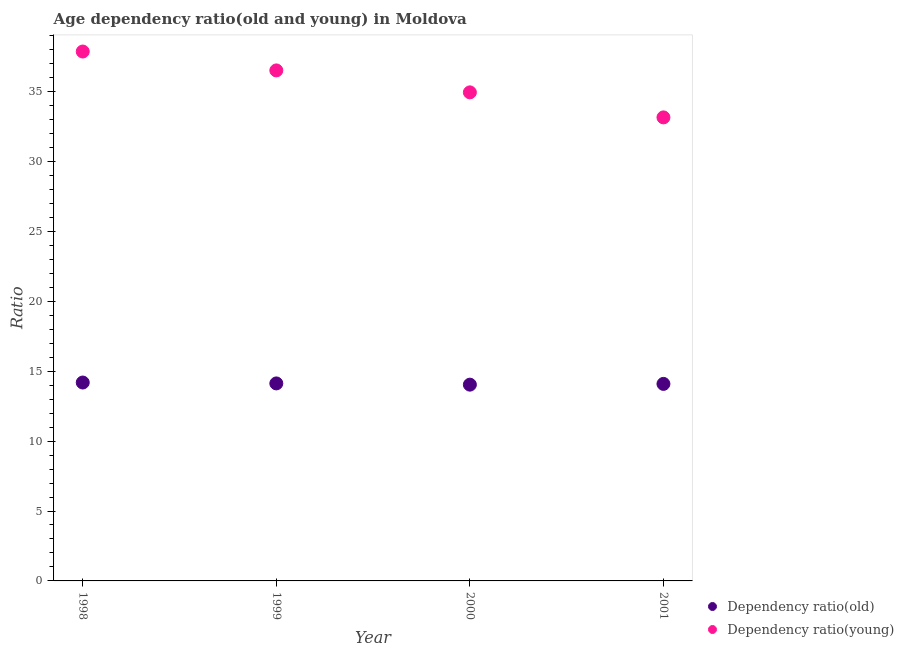Is the number of dotlines equal to the number of legend labels?
Offer a terse response. Yes. What is the age dependency ratio(young) in 1999?
Give a very brief answer. 36.51. Across all years, what is the maximum age dependency ratio(old)?
Keep it short and to the point. 14.19. Across all years, what is the minimum age dependency ratio(young)?
Provide a short and direct response. 33.15. What is the total age dependency ratio(young) in the graph?
Your answer should be compact. 142.48. What is the difference between the age dependency ratio(old) in 1999 and that in 2001?
Keep it short and to the point. 0.03. What is the difference between the age dependency ratio(old) in 2000 and the age dependency ratio(young) in 1998?
Offer a very short reply. -23.83. What is the average age dependency ratio(old) per year?
Ensure brevity in your answer.  14.11. In the year 2000, what is the difference between the age dependency ratio(young) and age dependency ratio(old)?
Provide a succinct answer. 20.91. In how many years, is the age dependency ratio(old) greater than 25?
Give a very brief answer. 0. What is the ratio of the age dependency ratio(young) in 1998 to that in 2001?
Your answer should be compact. 1.14. What is the difference between the highest and the second highest age dependency ratio(young)?
Offer a very short reply. 1.35. What is the difference between the highest and the lowest age dependency ratio(old)?
Give a very brief answer. 0.15. Does the age dependency ratio(old) monotonically increase over the years?
Ensure brevity in your answer.  No. Is the age dependency ratio(young) strictly greater than the age dependency ratio(old) over the years?
Give a very brief answer. Yes. How many dotlines are there?
Give a very brief answer. 2. How many years are there in the graph?
Your answer should be very brief. 4. Are the values on the major ticks of Y-axis written in scientific E-notation?
Provide a short and direct response. No. Where does the legend appear in the graph?
Offer a very short reply. Bottom right. How many legend labels are there?
Offer a terse response. 2. How are the legend labels stacked?
Your answer should be compact. Vertical. What is the title of the graph?
Your answer should be very brief. Age dependency ratio(old and young) in Moldova. What is the label or title of the Y-axis?
Keep it short and to the point. Ratio. What is the Ratio of Dependency ratio(old) in 1998?
Provide a short and direct response. 14.19. What is the Ratio in Dependency ratio(young) in 1998?
Give a very brief answer. 37.86. What is the Ratio in Dependency ratio(old) in 1999?
Give a very brief answer. 14.13. What is the Ratio in Dependency ratio(young) in 1999?
Provide a short and direct response. 36.51. What is the Ratio in Dependency ratio(old) in 2000?
Make the answer very short. 14.04. What is the Ratio in Dependency ratio(young) in 2000?
Your response must be concise. 34.94. What is the Ratio in Dependency ratio(old) in 2001?
Offer a terse response. 14.09. What is the Ratio in Dependency ratio(young) in 2001?
Give a very brief answer. 33.15. Across all years, what is the maximum Ratio of Dependency ratio(old)?
Provide a succinct answer. 14.19. Across all years, what is the maximum Ratio of Dependency ratio(young)?
Provide a succinct answer. 37.86. Across all years, what is the minimum Ratio of Dependency ratio(old)?
Give a very brief answer. 14.04. Across all years, what is the minimum Ratio in Dependency ratio(young)?
Keep it short and to the point. 33.15. What is the total Ratio in Dependency ratio(old) in the graph?
Provide a short and direct response. 56.45. What is the total Ratio in Dependency ratio(young) in the graph?
Your answer should be compact. 142.47. What is the difference between the Ratio in Dependency ratio(old) in 1998 and that in 1999?
Your response must be concise. 0.06. What is the difference between the Ratio in Dependency ratio(young) in 1998 and that in 1999?
Offer a terse response. 1.35. What is the difference between the Ratio in Dependency ratio(old) in 1998 and that in 2000?
Keep it short and to the point. 0.15. What is the difference between the Ratio in Dependency ratio(young) in 1998 and that in 2000?
Make the answer very short. 2.92. What is the difference between the Ratio of Dependency ratio(old) in 1998 and that in 2001?
Provide a succinct answer. 0.1. What is the difference between the Ratio in Dependency ratio(young) in 1998 and that in 2001?
Your response must be concise. 4.71. What is the difference between the Ratio of Dependency ratio(old) in 1999 and that in 2000?
Offer a terse response. 0.09. What is the difference between the Ratio in Dependency ratio(young) in 1999 and that in 2000?
Your response must be concise. 1.57. What is the difference between the Ratio of Dependency ratio(old) in 1999 and that in 2001?
Make the answer very short. 0.03. What is the difference between the Ratio in Dependency ratio(young) in 1999 and that in 2001?
Give a very brief answer. 3.36. What is the difference between the Ratio of Dependency ratio(old) in 2000 and that in 2001?
Your answer should be very brief. -0.05. What is the difference between the Ratio of Dependency ratio(young) in 2000 and that in 2001?
Ensure brevity in your answer.  1.79. What is the difference between the Ratio of Dependency ratio(old) in 1998 and the Ratio of Dependency ratio(young) in 1999?
Give a very brief answer. -22.32. What is the difference between the Ratio of Dependency ratio(old) in 1998 and the Ratio of Dependency ratio(young) in 2000?
Your response must be concise. -20.75. What is the difference between the Ratio in Dependency ratio(old) in 1998 and the Ratio in Dependency ratio(young) in 2001?
Give a very brief answer. -18.96. What is the difference between the Ratio in Dependency ratio(old) in 1999 and the Ratio in Dependency ratio(young) in 2000?
Ensure brevity in your answer.  -20.82. What is the difference between the Ratio of Dependency ratio(old) in 1999 and the Ratio of Dependency ratio(young) in 2001?
Your response must be concise. -19.03. What is the difference between the Ratio of Dependency ratio(old) in 2000 and the Ratio of Dependency ratio(young) in 2001?
Make the answer very short. -19.12. What is the average Ratio in Dependency ratio(old) per year?
Make the answer very short. 14.11. What is the average Ratio in Dependency ratio(young) per year?
Your answer should be compact. 35.62. In the year 1998, what is the difference between the Ratio of Dependency ratio(old) and Ratio of Dependency ratio(young)?
Offer a very short reply. -23.67. In the year 1999, what is the difference between the Ratio in Dependency ratio(old) and Ratio in Dependency ratio(young)?
Offer a very short reply. -22.39. In the year 2000, what is the difference between the Ratio in Dependency ratio(old) and Ratio in Dependency ratio(young)?
Provide a succinct answer. -20.91. In the year 2001, what is the difference between the Ratio in Dependency ratio(old) and Ratio in Dependency ratio(young)?
Ensure brevity in your answer.  -19.06. What is the ratio of the Ratio of Dependency ratio(old) in 1998 to that in 1999?
Ensure brevity in your answer.  1. What is the ratio of the Ratio of Dependency ratio(young) in 1998 to that in 1999?
Offer a very short reply. 1.04. What is the ratio of the Ratio of Dependency ratio(old) in 1998 to that in 2000?
Ensure brevity in your answer.  1.01. What is the ratio of the Ratio of Dependency ratio(young) in 1998 to that in 2000?
Provide a succinct answer. 1.08. What is the ratio of the Ratio of Dependency ratio(young) in 1998 to that in 2001?
Offer a terse response. 1.14. What is the ratio of the Ratio of Dependency ratio(young) in 1999 to that in 2000?
Your answer should be very brief. 1.04. What is the ratio of the Ratio of Dependency ratio(old) in 1999 to that in 2001?
Offer a very short reply. 1. What is the ratio of the Ratio in Dependency ratio(young) in 1999 to that in 2001?
Provide a short and direct response. 1.1. What is the ratio of the Ratio of Dependency ratio(old) in 2000 to that in 2001?
Make the answer very short. 1. What is the ratio of the Ratio of Dependency ratio(young) in 2000 to that in 2001?
Keep it short and to the point. 1.05. What is the difference between the highest and the second highest Ratio in Dependency ratio(old)?
Make the answer very short. 0.06. What is the difference between the highest and the second highest Ratio of Dependency ratio(young)?
Your answer should be very brief. 1.35. What is the difference between the highest and the lowest Ratio of Dependency ratio(old)?
Offer a terse response. 0.15. What is the difference between the highest and the lowest Ratio of Dependency ratio(young)?
Your response must be concise. 4.71. 